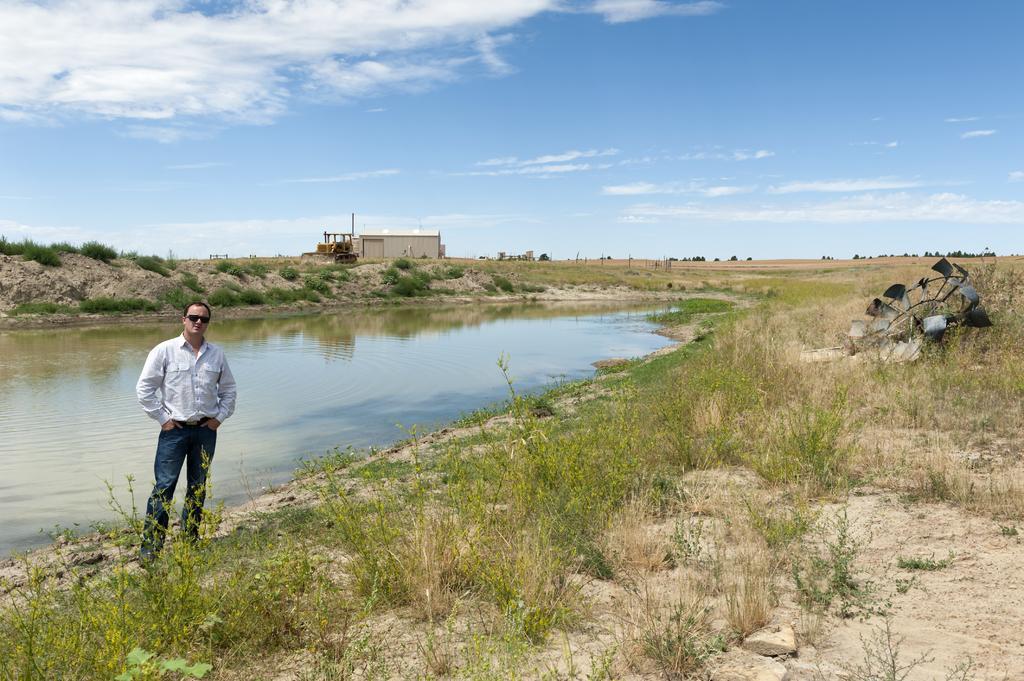Can you describe this image briefly? In this image, we can see a person standing and wearing glasses. In the background, there is a shed, trees and some objects. At the bottom, there is water and we can see planets on the ground. 